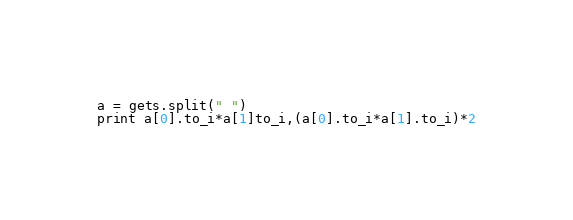<code> <loc_0><loc_0><loc_500><loc_500><_Ruby_>a = gets.split(" ")
print a[0].to_i*a[1]to_i,(a[0].to_i*a[1].to_i)*2</code> 